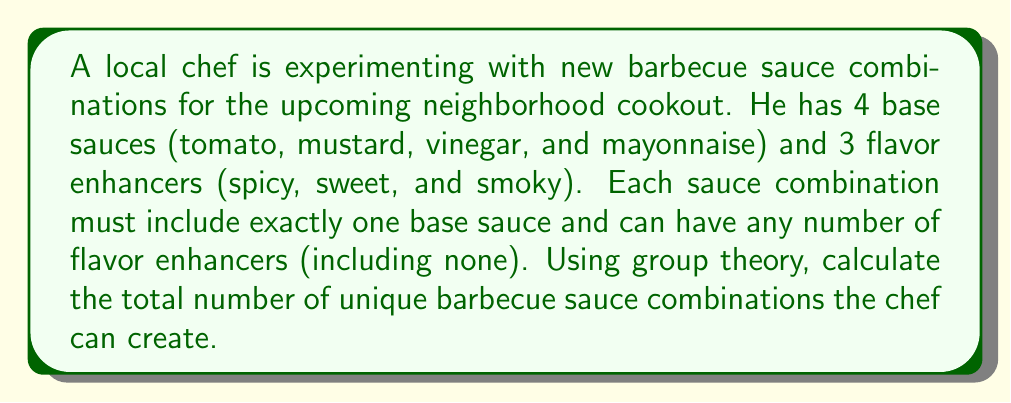Solve this math problem. To solve this problem using group theory, we can approach it as follows:

1) First, let's consider the base sauces. We have 4 choices, and we must choose exactly one. This can be represented as the symmetric group $S_4$.

2) For the flavor enhancers, we have 3 options, and we can choose any number of them (including none). This situation can be modeled using the direct product of three cyclic groups of order 2, denoted as $C_2 \times C_2 \times C_2$ or $(\mathbb{Z}/2\mathbb{Z})^3$.

3) The total number of combinations will be the product of the orders of these groups:

   $|S_4| \cdot |C_2 \times C_2 \times C_2|$

4) We know that $|S_4| = 4!$ (the order of the symmetric group on 4 elements is 4 factorial).

5) For $C_2 \times C_2 \times C_2$, each $C_2$ has order 2, so the order of the direct product is $2 \cdot 2 \cdot 2 = 8$.

6) Therefore, the total number of combinations is:

   $4! \cdot 8 = 24 \cdot 8 = 192$

This result can be interpreted as follows: for each of the 4 base sauces, we have 8 possible combinations of flavor enhancers (including using no enhancers), giving us $4 \cdot 8 = 32$ total combinations.
Answer: $192$ unique barbecue sauce combinations 